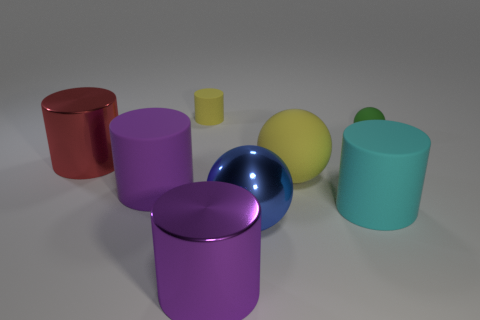How are the shadows distributed in this scene? The shadows in the scene are cast diagonally from the upper left to the lower right, suggesting a light source located to the left and above the objects. Each object casts a shadow in accordance with its shape, providing further depth and dimensionality to the composition. 